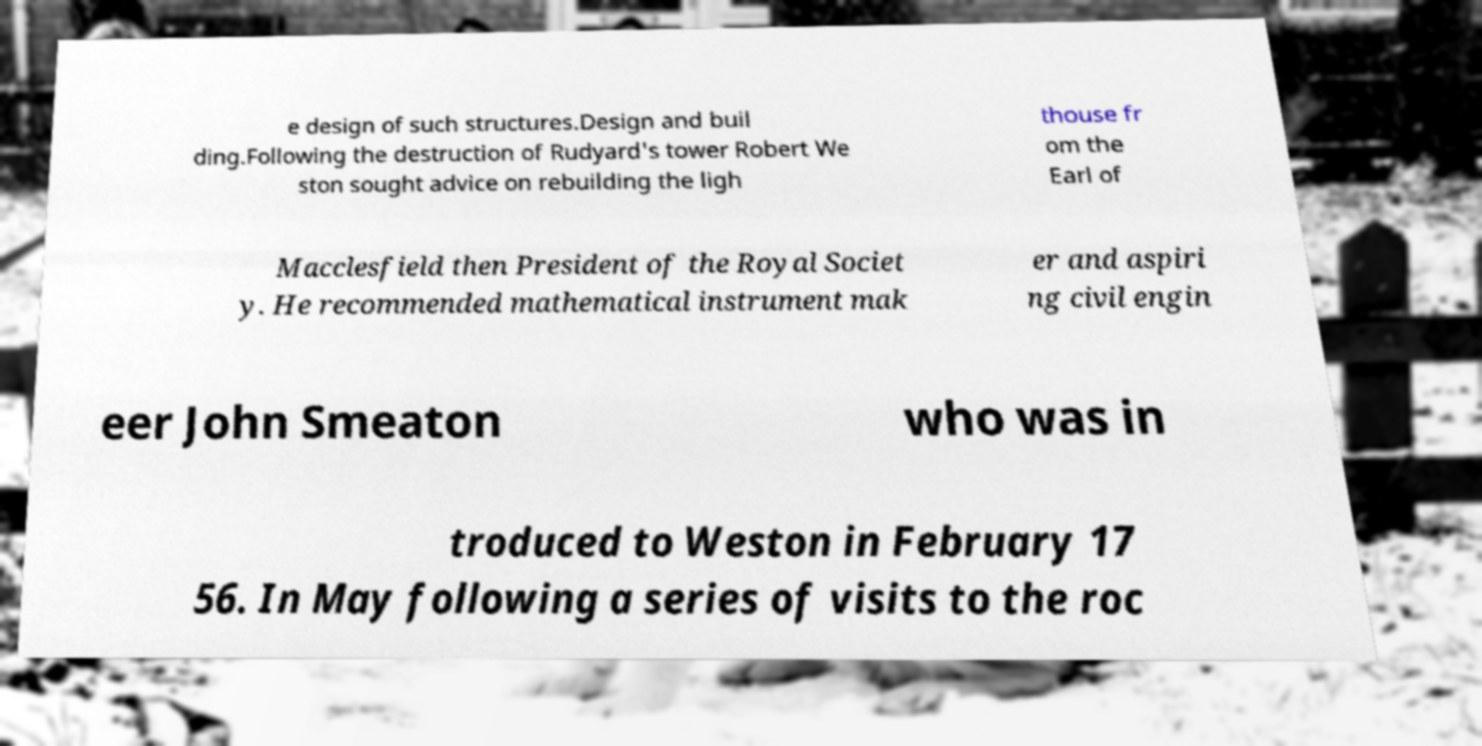Could you assist in decoding the text presented in this image and type it out clearly? e design of such structures.Design and buil ding.Following the destruction of Rudyard's tower Robert We ston sought advice on rebuilding the ligh thouse fr om the Earl of Macclesfield then President of the Royal Societ y. He recommended mathematical instrument mak er and aspiri ng civil engin eer John Smeaton who was in troduced to Weston in February 17 56. In May following a series of visits to the roc 